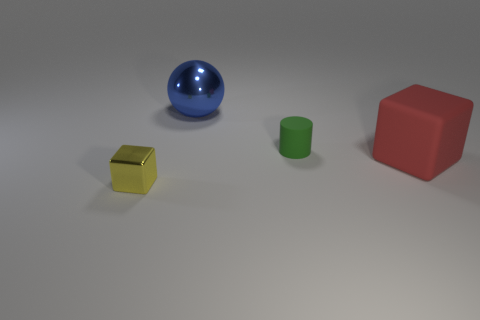Is there anything else that is the same shape as the small rubber thing?
Your answer should be compact. No. What shape is the object that is the same size as the green cylinder?
Offer a terse response. Cube. How big is the rubber cylinder?
Provide a short and direct response. Small. Do the blue sphere that is to the right of the yellow block and the metal object that is in front of the small green cylinder have the same size?
Offer a very short reply. No. What is the color of the shiny thing behind the large thing to the right of the tiny green cylinder?
Your answer should be very brief. Blue. What material is the cube that is the same size as the green thing?
Make the answer very short. Metal. How many matte things are either big blue spheres or small blue objects?
Your answer should be very brief. 0. There is a object that is in front of the green thing and on the right side of the ball; what is its color?
Give a very brief answer. Red. What number of balls are behind the large sphere?
Ensure brevity in your answer.  0. What material is the large sphere?
Give a very brief answer. Metal. 